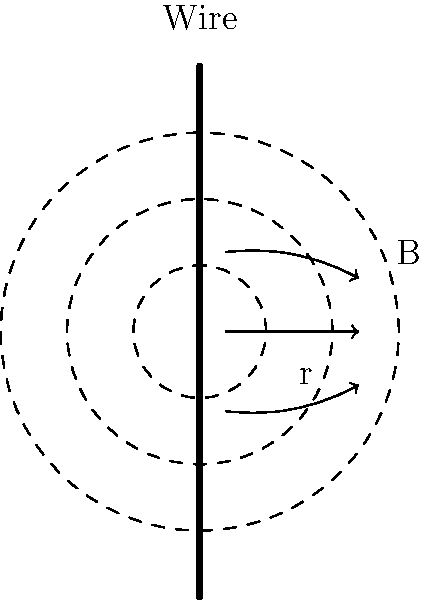In the 2004 presidential race, John Kerry emphasized the importance of energy policy. Considering a straight current-carrying wire, how does the magnetic field strength (B) vary with distance (r) from the wire's center? To answer this question, let's follow these steps:

1. Recall Ampère's law for a long, straight wire: The magnetic field strength B is proportional to the current I and inversely proportional to the distance r from the wire's center.

2. The mathematical expression for this relationship is:

   $$B = \frac{\mu_0 I}{2\pi r}$$

   Where $\mu_0$ is the permeability of free space, a constant.

3. Examining this equation, we can see that as r increases, B decreases.

4. More specifically, B is inversely proportional to r. This means that if we double the distance from the wire, the magnetic field strength will be halved.

5. In the diagram, the concentric circles represent points of equal magnetic field strength. As we move further from the wire (increasing r), the circles get farther apart, indicating a decrease in the rate of change of the magnetic field strength.

6. This inverse relationship between B and r is crucial for understanding electromagnetic fields, which play a significant role in energy policy and technology - topics that were important in Kerry's 2004 campaign.

Therefore, the magnetic field strength decreases inversely with distance from the wire's center.
Answer: $B \propto \frac{1}{r}$ 